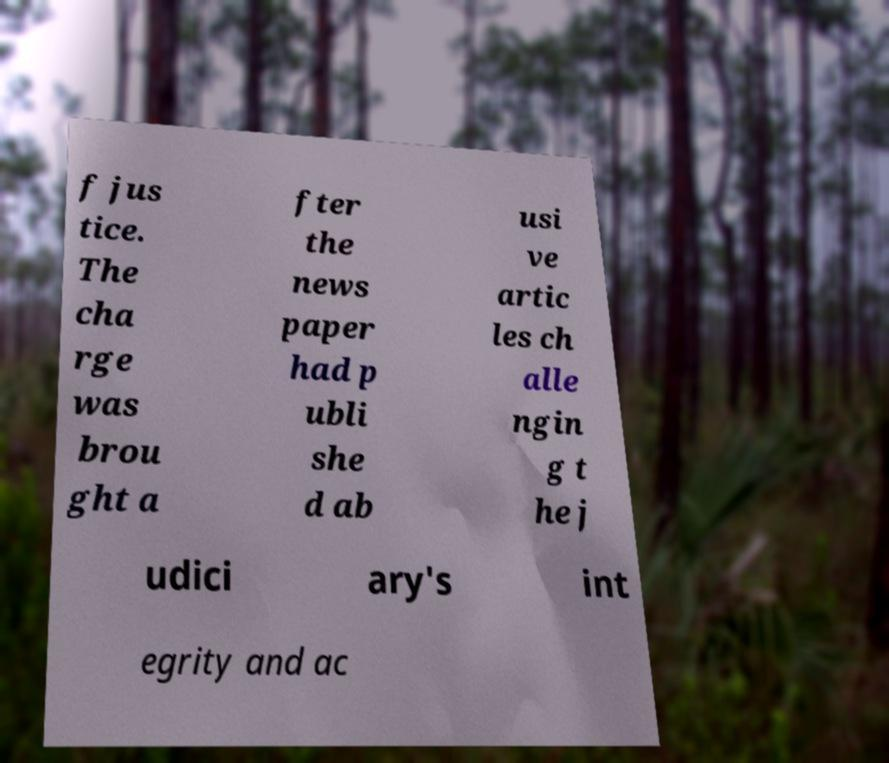Can you read and provide the text displayed in the image?This photo seems to have some interesting text. Can you extract and type it out for me? f jus tice. The cha rge was brou ght a fter the news paper had p ubli she d ab usi ve artic les ch alle ngin g t he j udici ary's int egrity and ac 